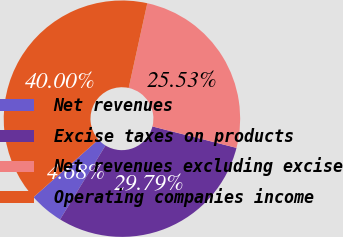Convert chart. <chart><loc_0><loc_0><loc_500><loc_500><pie_chart><fcel>Net revenues<fcel>Excise taxes on products<fcel>Net revenues excluding excise<fcel>Operating companies income<nl><fcel>4.68%<fcel>29.79%<fcel>25.53%<fcel>40.0%<nl></chart> 